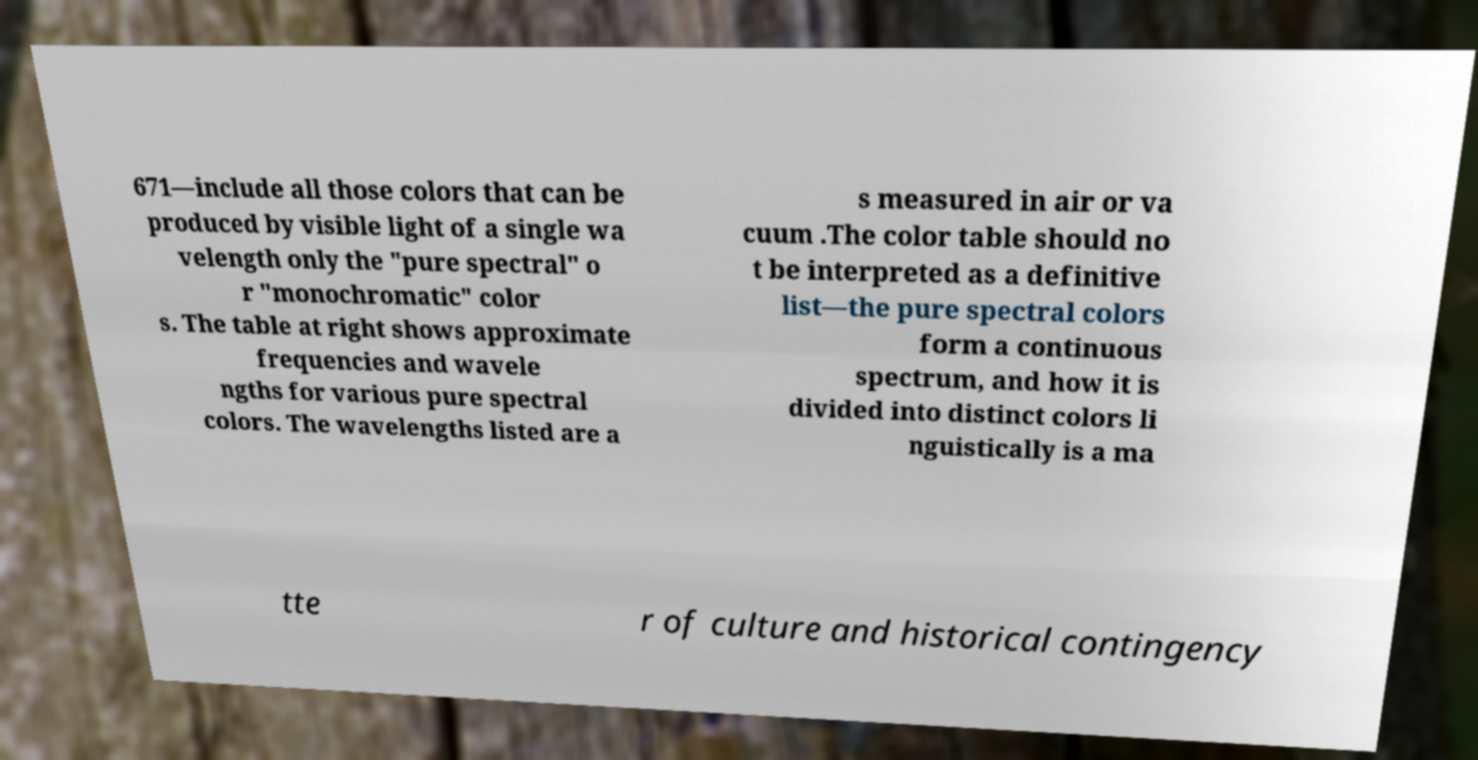There's text embedded in this image that I need extracted. Can you transcribe it verbatim? 671—include all those colors that can be produced by visible light of a single wa velength only the "pure spectral" o r "monochromatic" color s. The table at right shows approximate frequencies and wavele ngths for various pure spectral colors. The wavelengths listed are a s measured in air or va cuum .The color table should no t be interpreted as a definitive list—the pure spectral colors form a continuous spectrum, and how it is divided into distinct colors li nguistically is a ma tte r of culture and historical contingency 